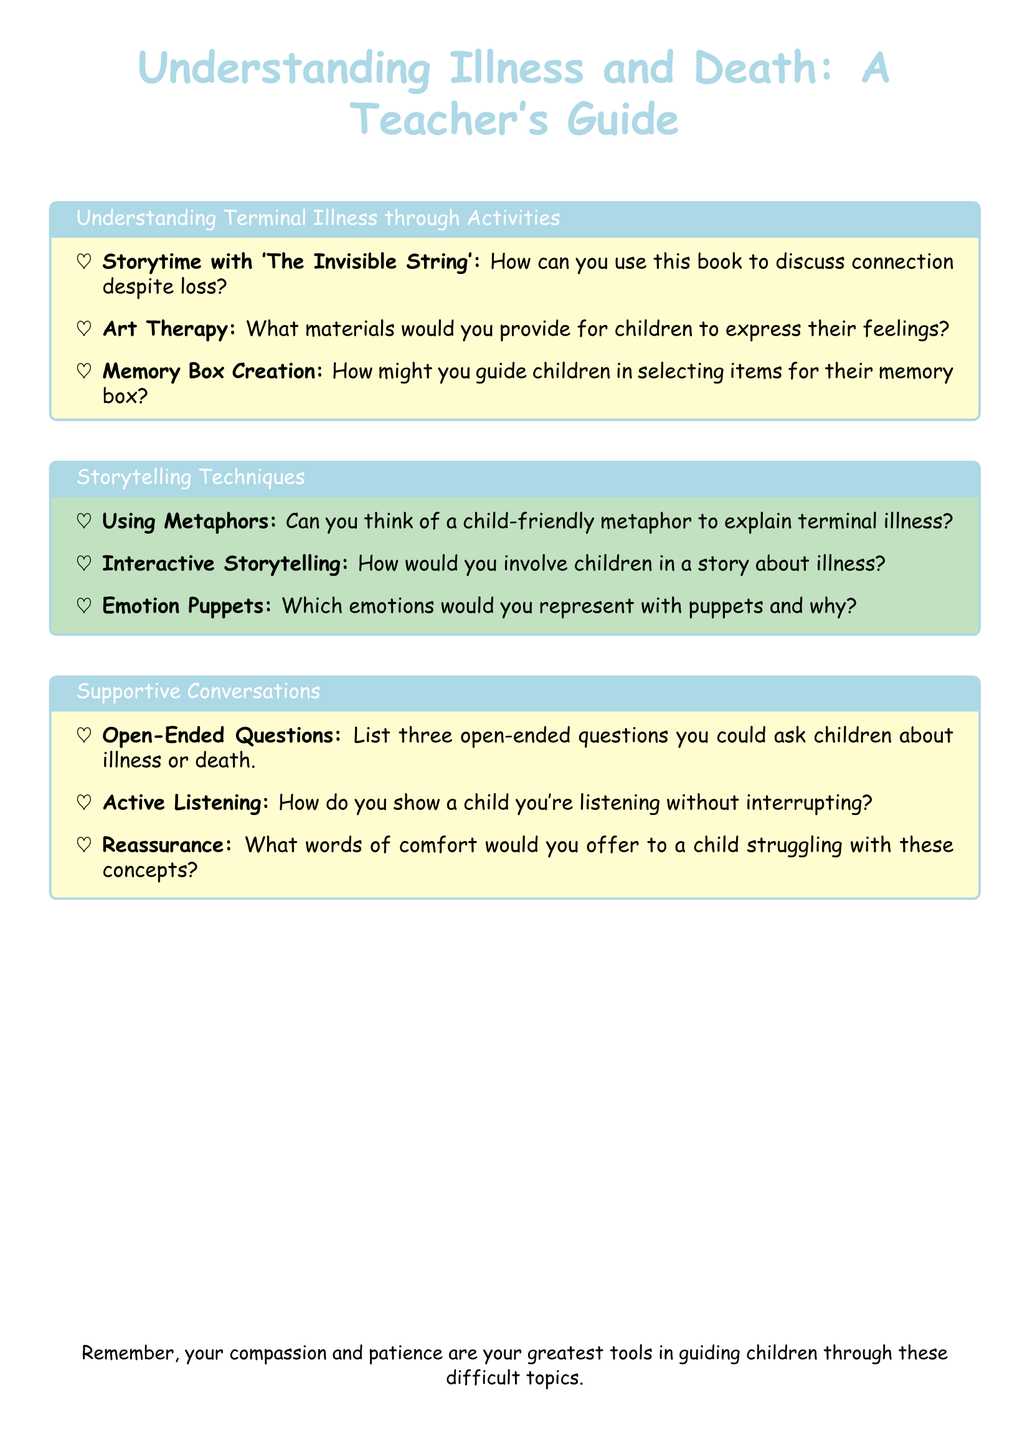What is the title of the document? The title of the document is the main heading displayed at the top of the document.
Answer: Understanding Illness and Death: A Teacher's Guide What color is used for section titles? The document specifies a color for section titles in the formatting instructions.
Answer: pastelblue Name one activity mentioned for understanding terminal illness. The document lists specific activities designed to help children understand illness.
Answer: Memory Box Creation What storytelling technique involves children participating in a narrative? The document provides techniques for storytelling about illness and death, focusing on interactive methods.
Answer: Interactive Storytelling How many open-ended questions are suggested to ask children about illness or death? The document explicitly mentions a number of questions that could be asked.
Answer: three Which emotion is suggested to be represented with puppets? The document hints at ways to explore emotions using puppets, encouraging emotional expression.
Answer: emotions What is one of the supportive conversation techniques mentioned? The document outlines specific techniques to facilitate conversations with children about difficult topics.
Answer: Active Listening What type of therapy is mentioned for helping children express their feelings? The document discusses a specific type of therapeutic activity related to art.
Answer: Art Therapy What should you remember while guiding children through these topics? The document concludes with a reminder about a crucial quality needed for dealing with illness and death with children.
Answer: compassion and patience 